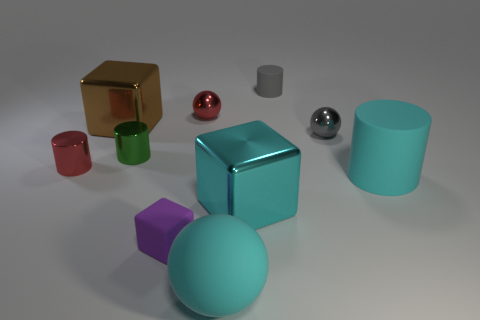Which object in the image appears to be the most reflective, and what color is it? The most reflective object is the chrome-like sphere located towards the middle of the image, to the left side. It has a mirror-like surface that reflects its surroundings, making it appear metallic and highly reflective. 